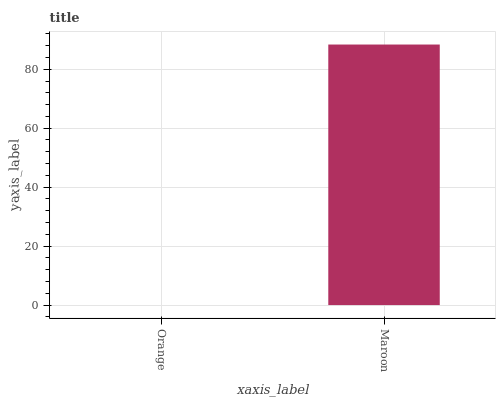Is Orange the minimum?
Answer yes or no. Yes. Is Maroon the maximum?
Answer yes or no. Yes. Is Maroon the minimum?
Answer yes or no. No. Is Maroon greater than Orange?
Answer yes or no. Yes. Is Orange less than Maroon?
Answer yes or no. Yes. Is Orange greater than Maroon?
Answer yes or no. No. Is Maroon less than Orange?
Answer yes or no. No. Is Maroon the high median?
Answer yes or no. Yes. Is Orange the low median?
Answer yes or no. Yes. Is Orange the high median?
Answer yes or no. No. Is Maroon the low median?
Answer yes or no. No. 